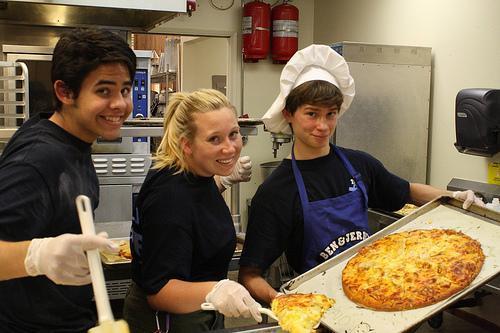How many people are in this picture?
Give a very brief answer. 3. 